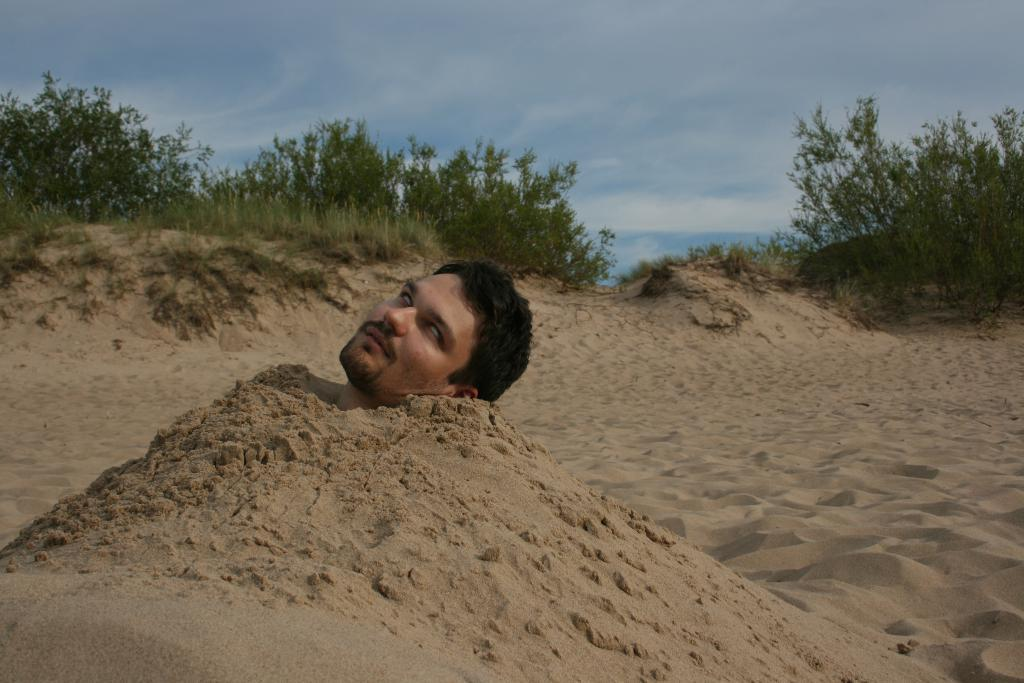What is the main subject of the image? There is a man in the sand in the image. Where is the man located in the image? The man is in the middle of the image. What can be seen in the background of the image? There are trees in the background of the image. What is visible at the top of the image? The sky is visible at the top of the image. How many ducks are swimming in the sand in the image? There are no ducks present in the image; it features a man in the sand. What type of hope can be seen growing in the sand in the image? There is no hope growing in the sand in the image; it only features a man and the surrounding environment. 